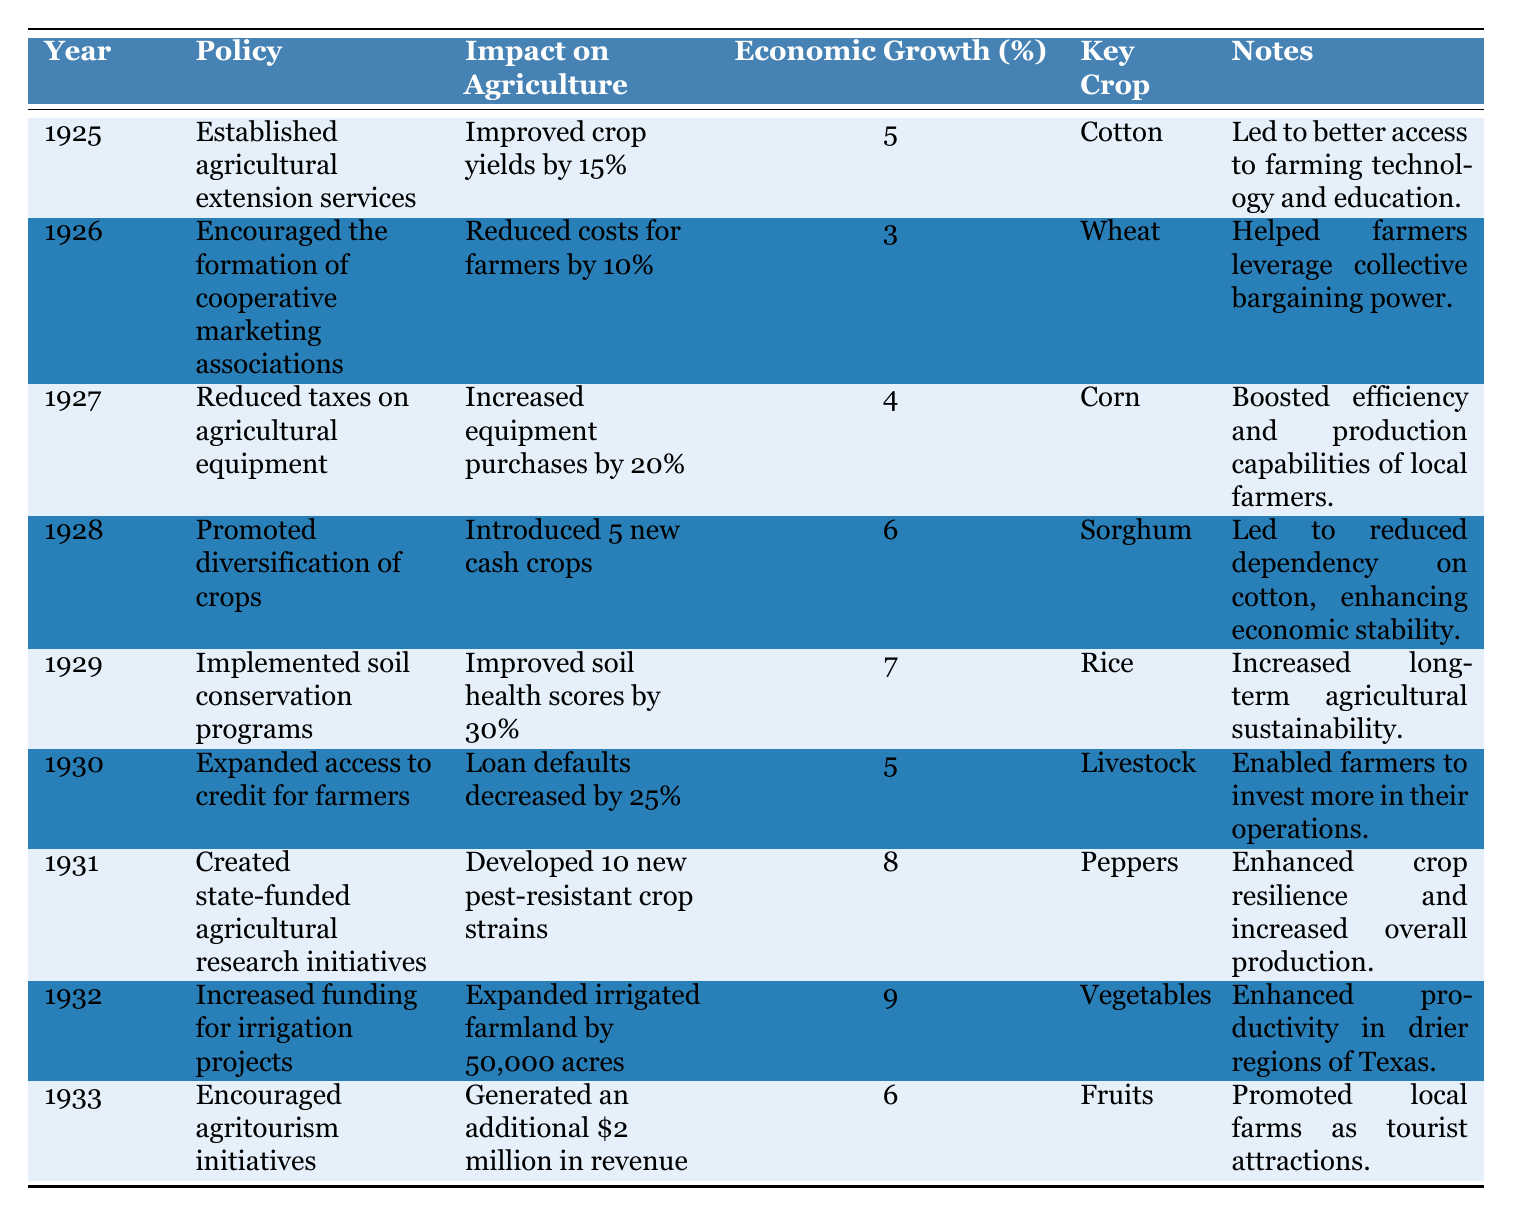What year did Governor Miriam A. Ferguson establish agricultural extension services? The table lists the year 1925 for the establishment of agricultural extension services.
Answer: 1925 What was the impact on agriculture in 1929? The impact on agriculture in 1929 was improved soil health scores by 30%.
Answer: Improved soil health scores by 30% Which policy reduced costs for farmers by 10%? The policy that reduced costs for farmers by 10% was the encouragement of the formation of cooperative marketing associations in 1926.
Answer: Encouraged the formation of cooperative marketing associations What is the average economic growth percentage from the years listed? The economic growth percentages are 5, 3, 4, 6, 7, 5, 8, 9, and 6. Summing these gives 5 + 3 + 4 + 6 + 7 + 5 + 8 + 9 + 6 = 53. There are 9 data points, so the average is 53/9 = 5.89.
Answer: 5.89 Which key crop had the highest economic growth associated with its policy? The key crop with the highest economic growth was "Vegetables" in 1932, which had an economic growth percentage of 9.
Answer: Vegetables Did the implementation of soil conservation programs improve soil health? Yes, the implementation of soil conservation programs improved soil health scores by 30%.
Answer: Yes What was the economic growth percentage in 1931 compared to 1926? The economic growth percentage in 1931 was 8%, while in 1926 it was 3%. The difference is 8 - 3 = 5%.
Answer: 5% Which year saw the development of 10 new pest-resistant crop strains? The year that saw the development of 10 new pest-resistant crop strains was 1931.
Answer: 1931 What percentage increase in economic growth was observed in 1932 due to increased funding for irrigation projects? The economic growth percentage observed in 1932 was 9%.
Answer: 9% Which policy aimed at promoting crop diversification? The policy aimed at promoting crop diversification was implemented in 1928 and introduced 5 new cash crops.
Answer: Promoted diversification of crops Calculate the economic growth difference between the policies in 1931 and 1930. The economic growth percentage in 1931 was 8%, and in 1930 it was 5%. The difference is 8 - 5 = 3%.
Answer: 3% 